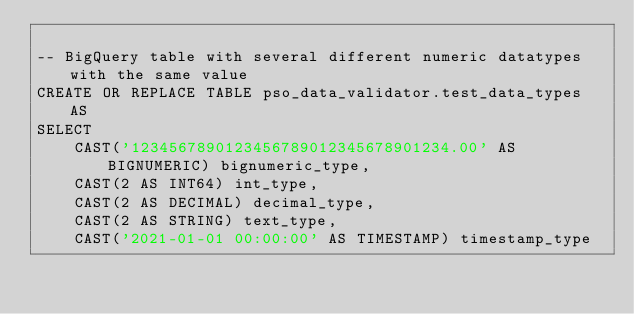Convert code to text. <code><loc_0><loc_0><loc_500><loc_500><_SQL_>
-- BigQuery table with several different numeric datatypes with the same value
CREATE OR REPLACE TABLE pso_data_validator.test_data_types AS
SELECT
    CAST('1234567890123456789012345678901234.00' AS BIGNUMERIC) bignumeric_type,
    CAST(2 AS INT64) int_type,
    CAST(2 AS DECIMAL) decimal_type,
    CAST(2 AS STRING) text_type,
    CAST('2021-01-01 00:00:00' AS TIMESTAMP) timestamp_type

</code> 